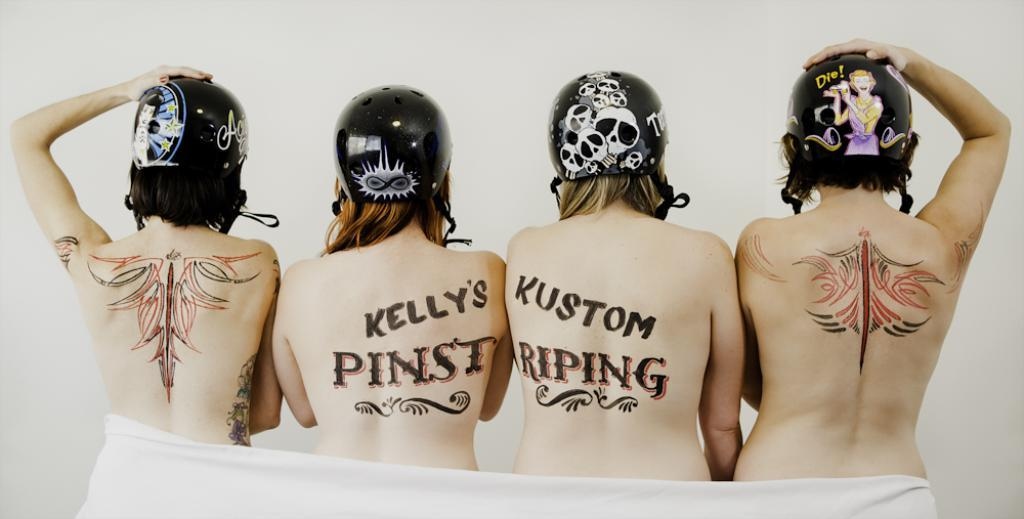What can be seen in the image? There are people standing in the image. What are the people wearing on their heads? The people are wearing helmets. What is unique about the helmets? The helmets have logos and text on them. What is visible in the background of the image? There is a wall in the background of the image. How far does the brain extend in the image? There is no brain visible in the image; it features people wearing helmets with logos and text. 